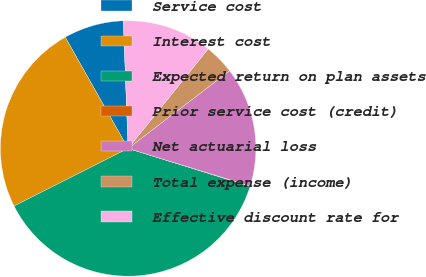<chart> <loc_0><loc_0><loc_500><loc_500><pie_chart><fcel>Service cost<fcel>Interest cost<fcel>Expected return on plan assets<fcel>Prior service cost (credit)<fcel>Net actuarial loss<fcel>Total expense (income)<fcel>Effective discount rate for<nl><fcel>7.6%<fcel>24.26%<fcel>37.76%<fcel>0.05%<fcel>15.14%<fcel>3.83%<fcel>11.37%<nl></chart> 